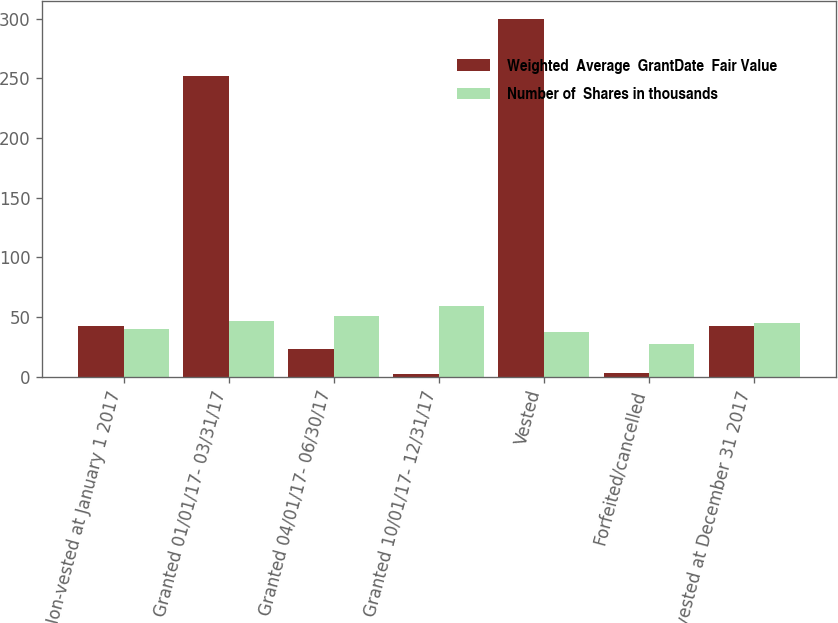<chart> <loc_0><loc_0><loc_500><loc_500><stacked_bar_chart><ecel><fcel>Non-vested at January 1 2017<fcel>Granted 01/01/17- 03/31/17<fcel>Granted 04/01/17- 06/30/17<fcel>Granted 10/01/17- 12/31/17<fcel>Vested<fcel>Forfeited/cancelled<fcel>Non-vested at December 31 2017<nl><fcel>Weighted  Average  GrantDate  Fair Value<fcel>42.52<fcel>252<fcel>23<fcel>2<fcel>300<fcel>3<fcel>42.52<nl><fcel>Number of  Shares in thousands<fcel>39.95<fcel>46.27<fcel>50.86<fcel>59.43<fcel>37.26<fcel>27.02<fcel>45.09<nl></chart> 